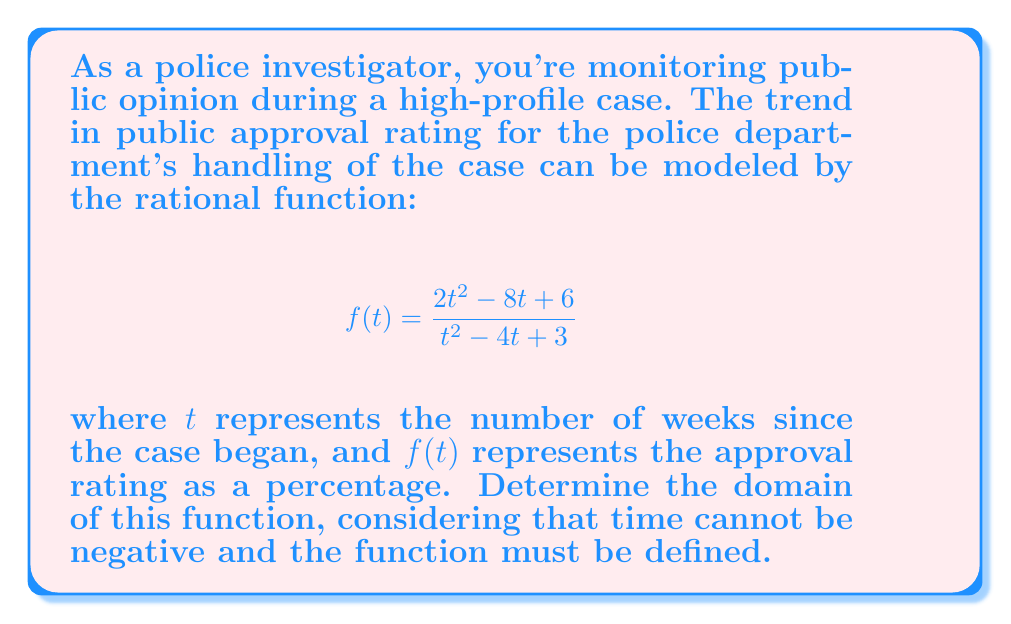Can you answer this question? To determine the domain of this rational function, we need to consider two factors:

1. The restriction on $t$ (time cannot be negative)
2. Values that make the denominator zero (undefined points)

Step 1: Time restriction
Since $t$ represents weeks, we know that $t \geq 0$.

Step 2: Find values that make the denominator zero
Set the denominator equal to zero and solve:
$$t^2 - 4t + 3 = 0$$

This is a quadratic equation. We can solve it using the quadratic formula:
$$t = \frac{-b \pm \sqrt{b^2 - 4ac}}{2a}$$

Where $a=1$, $b=-4$, and $c=3$

$$t = \frac{4 \pm \sqrt{16 - 12}}{2} = \frac{4 \pm \sqrt{4}}{2} = \frac{4 \pm 2}{2}$$

This gives us two solutions:
$$t = \frac{4 + 2}{2} = 3$$ or $$t = \frac{4 - 2}{2} = 1$$

Step 3: Combine the restrictions
The function is undefined when $t = 1$ or $t = 3$, and $t$ must be non-negative.

Therefore, the domain is all non-negative real numbers except 1 and 3, which can be expressed as:

$$\{t \in \mathbb{R} : t \geq 0, t \neq 1, t \neq 3\}$$
Answer: $\{t \in \mathbb{R} : t \geq 0, t \neq 1, t \neq 3\}$ 